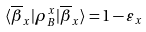<formula> <loc_0><loc_0><loc_500><loc_500>\langle \overline { \beta } _ { x } | \rho _ { B } ^ { x } | \overline { \beta } _ { x } \rangle = 1 - \varepsilon _ { x }</formula> 